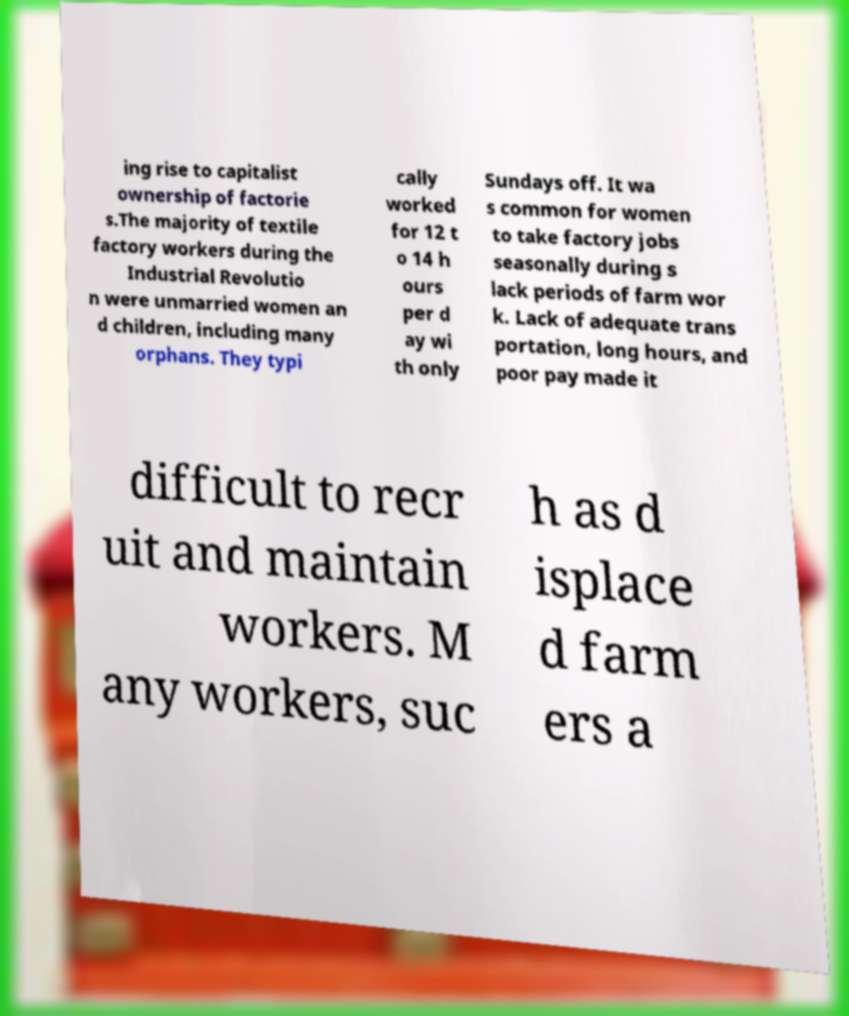Please read and relay the text visible in this image. What does it say? ing rise to capitalist ownership of factorie s.The majority of textile factory workers during the Industrial Revolutio n were unmarried women an d children, including many orphans. They typi cally worked for 12 t o 14 h ours per d ay wi th only Sundays off. It wa s common for women to take factory jobs seasonally during s lack periods of farm wor k. Lack of adequate trans portation, long hours, and poor pay made it difficult to recr uit and maintain workers. M any workers, suc h as d isplace d farm ers a 